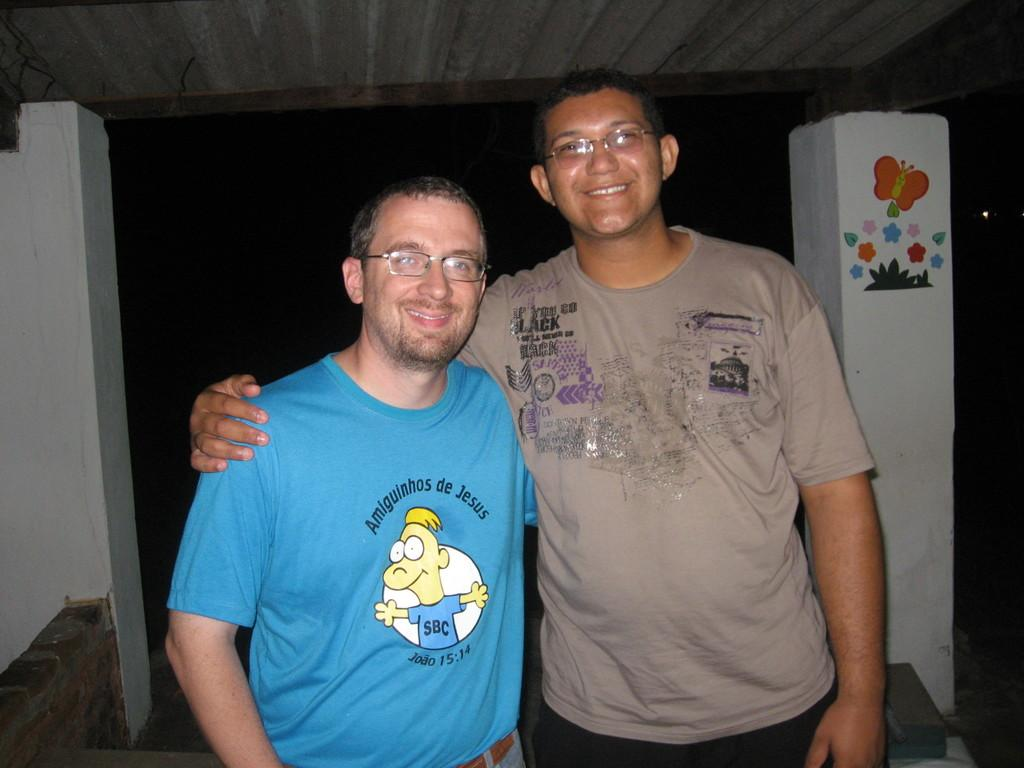How many people are in the image? There are two men in the image. What expressions do the men have? The men are smiling in the image. What are the men wearing? The men are wearing spectacles in the image. What can be seen in the background of the image? There is a pillar, a painting, and a wall in the image. What is the color of the background in the image? The background of the image is dark. Can you see any mist in the image? There is no mist present in the image. What type of bucket is being used by the men in the image? There is no bucket visible in the image. 